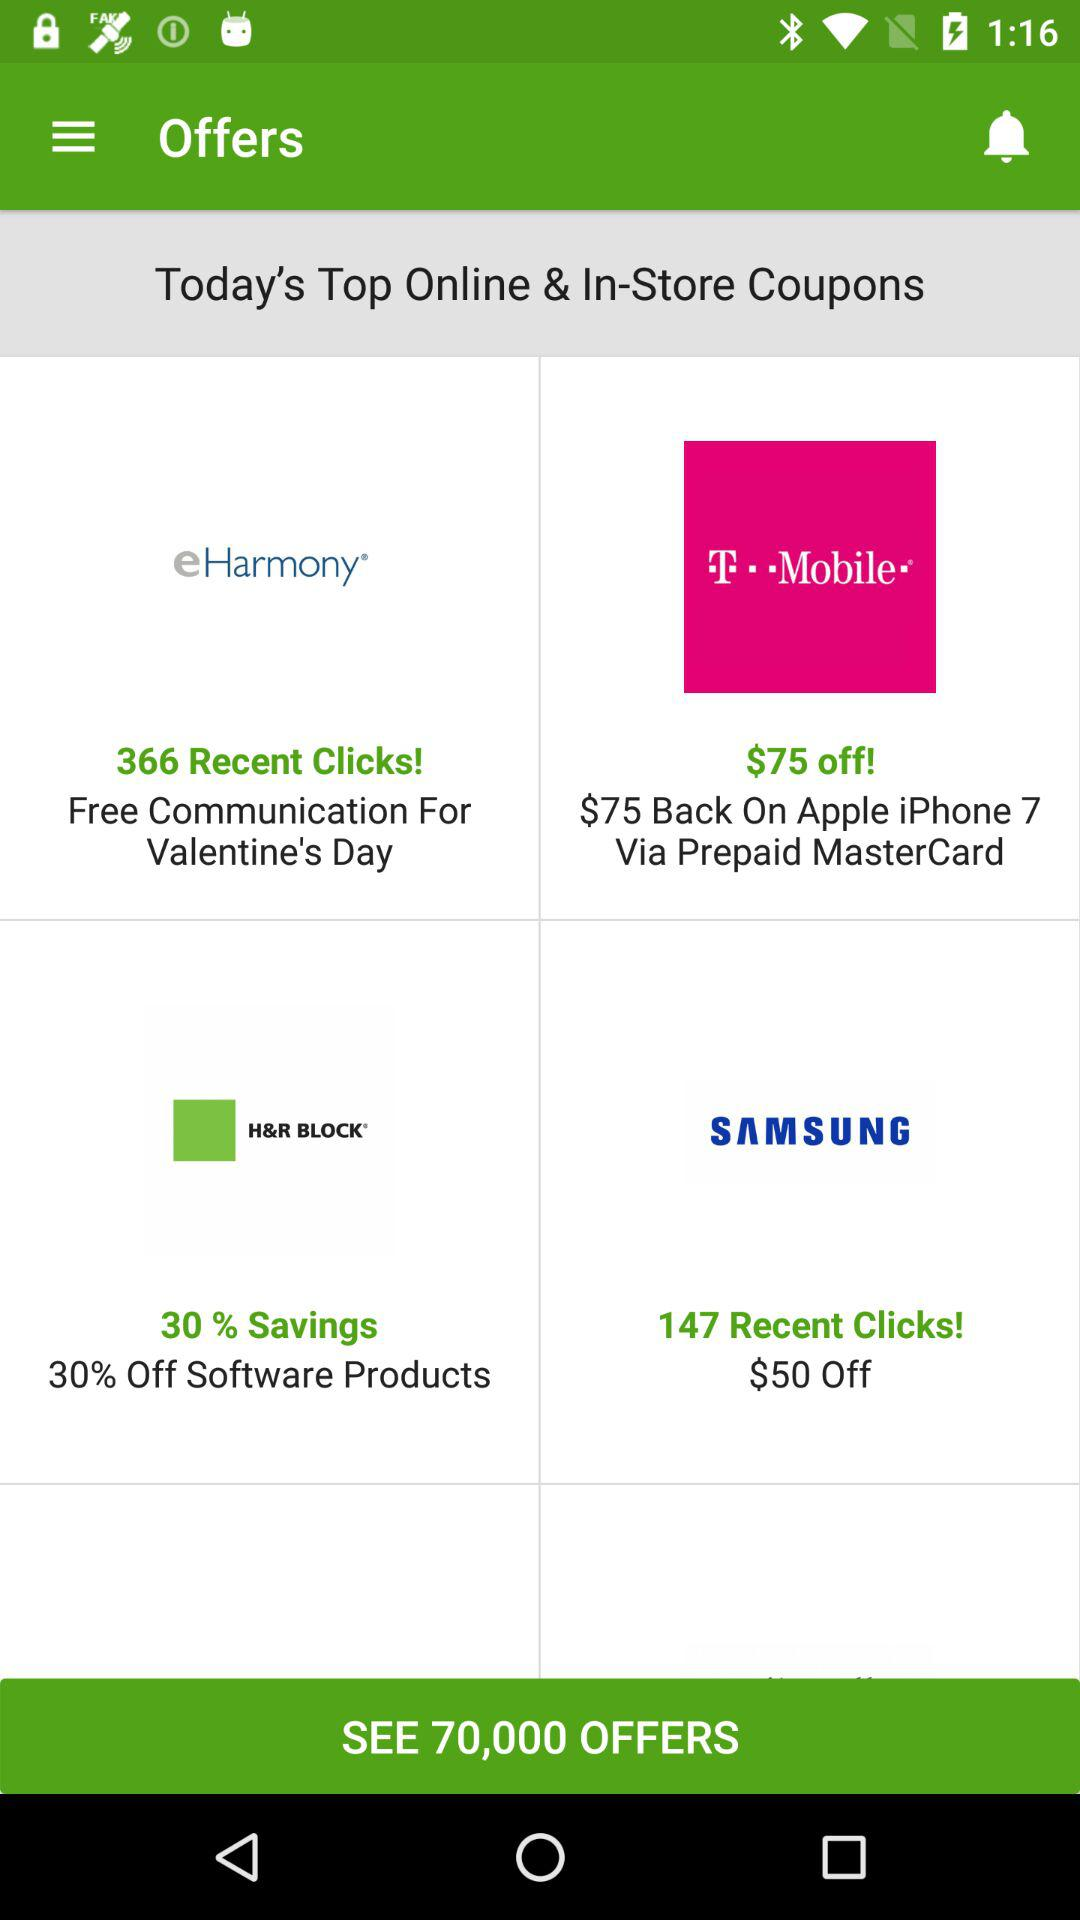For what product are there 147 recent clicks? The product is "SAMSUNG". 